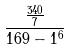Convert formula to latex. <formula><loc_0><loc_0><loc_500><loc_500>\frac { \frac { 3 4 0 } { 7 } } { 1 6 9 - 1 ^ { 6 } }</formula> 